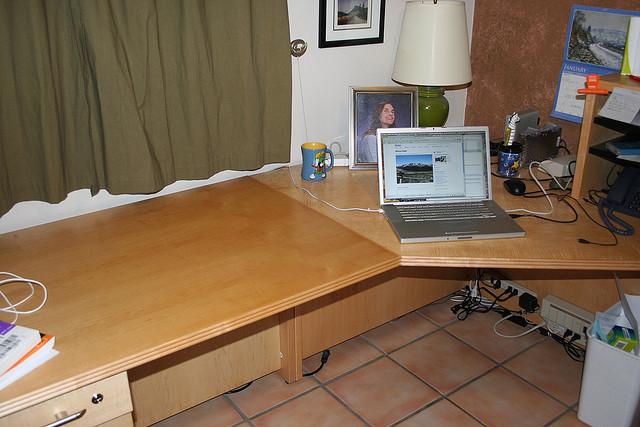What has the person been looking at on the laptop?
Short answer required. Picture. Is there a window in the room?
Keep it brief. Yes. Are there family pictures in the image?
Answer briefly. Yes. 